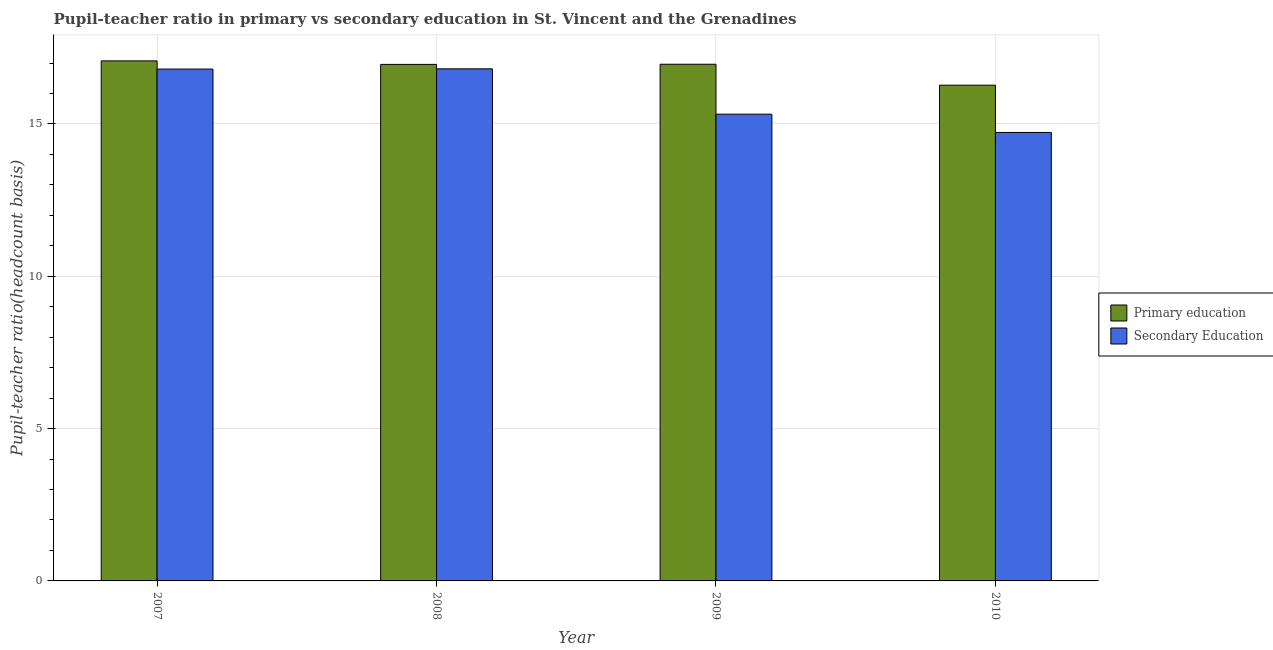How many groups of bars are there?
Offer a terse response. 4. Are the number of bars per tick equal to the number of legend labels?
Provide a succinct answer. Yes. Are the number of bars on each tick of the X-axis equal?
Your answer should be compact. Yes. How many bars are there on the 4th tick from the left?
Offer a terse response. 2. In how many cases, is the number of bars for a given year not equal to the number of legend labels?
Provide a succinct answer. 0. What is the pupil teacher ratio on secondary education in 2008?
Your answer should be very brief. 16.81. Across all years, what is the maximum pupil-teacher ratio in primary education?
Your response must be concise. 17.07. Across all years, what is the minimum pupil-teacher ratio in primary education?
Give a very brief answer. 16.27. In which year was the pupil-teacher ratio in primary education minimum?
Your answer should be very brief. 2010. What is the total pupil teacher ratio on secondary education in the graph?
Your response must be concise. 63.66. What is the difference between the pupil teacher ratio on secondary education in 2008 and that in 2010?
Keep it short and to the point. 2.09. What is the difference between the pupil teacher ratio on secondary education in 2008 and the pupil-teacher ratio in primary education in 2010?
Ensure brevity in your answer.  2.09. What is the average pupil teacher ratio on secondary education per year?
Your answer should be very brief. 15.91. In the year 2007, what is the difference between the pupil teacher ratio on secondary education and pupil-teacher ratio in primary education?
Make the answer very short. 0. In how many years, is the pupil teacher ratio on secondary education greater than 11?
Offer a very short reply. 4. What is the ratio of the pupil teacher ratio on secondary education in 2007 to that in 2008?
Your answer should be compact. 1. Is the pupil teacher ratio on secondary education in 2008 less than that in 2009?
Offer a very short reply. No. Is the difference between the pupil-teacher ratio in primary education in 2007 and 2009 greater than the difference between the pupil teacher ratio on secondary education in 2007 and 2009?
Offer a terse response. No. What is the difference between the highest and the second highest pupil teacher ratio on secondary education?
Provide a short and direct response. 0.01. What is the difference between the highest and the lowest pupil-teacher ratio in primary education?
Your answer should be very brief. 0.8. In how many years, is the pupil teacher ratio on secondary education greater than the average pupil teacher ratio on secondary education taken over all years?
Your answer should be very brief. 2. Is the sum of the pupil teacher ratio on secondary education in 2008 and 2009 greater than the maximum pupil-teacher ratio in primary education across all years?
Ensure brevity in your answer.  Yes. What does the 1st bar from the left in 2007 represents?
Ensure brevity in your answer.  Primary education. What does the 2nd bar from the right in 2010 represents?
Your answer should be very brief. Primary education. What is the difference between two consecutive major ticks on the Y-axis?
Your answer should be compact. 5. Are the values on the major ticks of Y-axis written in scientific E-notation?
Make the answer very short. No. Does the graph contain any zero values?
Keep it short and to the point. No. What is the title of the graph?
Your response must be concise. Pupil-teacher ratio in primary vs secondary education in St. Vincent and the Grenadines. What is the label or title of the Y-axis?
Ensure brevity in your answer.  Pupil-teacher ratio(headcount basis). What is the Pupil-teacher ratio(headcount basis) of Primary education in 2007?
Your answer should be compact. 17.07. What is the Pupil-teacher ratio(headcount basis) in Secondary Education in 2007?
Offer a terse response. 16.8. What is the Pupil-teacher ratio(headcount basis) in Primary education in 2008?
Offer a terse response. 16.96. What is the Pupil-teacher ratio(headcount basis) of Secondary Education in 2008?
Provide a succinct answer. 16.81. What is the Pupil-teacher ratio(headcount basis) in Primary education in 2009?
Provide a short and direct response. 16.96. What is the Pupil-teacher ratio(headcount basis) of Secondary Education in 2009?
Provide a succinct answer. 15.32. What is the Pupil-teacher ratio(headcount basis) in Primary education in 2010?
Keep it short and to the point. 16.27. What is the Pupil-teacher ratio(headcount basis) of Secondary Education in 2010?
Your answer should be very brief. 14.72. Across all years, what is the maximum Pupil-teacher ratio(headcount basis) in Primary education?
Make the answer very short. 17.07. Across all years, what is the maximum Pupil-teacher ratio(headcount basis) in Secondary Education?
Offer a very short reply. 16.81. Across all years, what is the minimum Pupil-teacher ratio(headcount basis) in Primary education?
Keep it short and to the point. 16.27. Across all years, what is the minimum Pupil-teacher ratio(headcount basis) of Secondary Education?
Your answer should be very brief. 14.72. What is the total Pupil-teacher ratio(headcount basis) of Primary education in the graph?
Keep it short and to the point. 67.26. What is the total Pupil-teacher ratio(headcount basis) in Secondary Education in the graph?
Your answer should be compact. 63.66. What is the difference between the Pupil-teacher ratio(headcount basis) in Primary education in 2007 and that in 2008?
Make the answer very short. 0.12. What is the difference between the Pupil-teacher ratio(headcount basis) in Secondary Education in 2007 and that in 2008?
Ensure brevity in your answer.  -0.01. What is the difference between the Pupil-teacher ratio(headcount basis) of Primary education in 2007 and that in 2009?
Your answer should be compact. 0.11. What is the difference between the Pupil-teacher ratio(headcount basis) in Secondary Education in 2007 and that in 2009?
Offer a very short reply. 1.48. What is the difference between the Pupil-teacher ratio(headcount basis) in Primary education in 2007 and that in 2010?
Give a very brief answer. 0.8. What is the difference between the Pupil-teacher ratio(headcount basis) of Secondary Education in 2007 and that in 2010?
Provide a short and direct response. 2.08. What is the difference between the Pupil-teacher ratio(headcount basis) in Primary education in 2008 and that in 2009?
Offer a terse response. -0.01. What is the difference between the Pupil-teacher ratio(headcount basis) of Secondary Education in 2008 and that in 2009?
Keep it short and to the point. 1.49. What is the difference between the Pupil-teacher ratio(headcount basis) in Primary education in 2008 and that in 2010?
Provide a succinct answer. 0.68. What is the difference between the Pupil-teacher ratio(headcount basis) of Secondary Education in 2008 and that in 2010?
Keep it short and to the point. 2.09. What is the difference between the Pupil-teacher ratio(headcount basis) in Primary education in 2009 and that in 2010?
Your answer should be compact. 0.69. What is the difference between the Pupil-teacher ratio(headcount basis) in Secondary Education in 2009 and that in 2010?
Your answer should be very brief. 0.6. What is the difference between the Pupil-teacher ratio(headcount basis) of Primary education in 2007 and the Pupil-teacher ratio(headcount basis) of Secondary Education in 2008?
Provide a succinct answer. 0.26. What is the difference between the Pupil-teacher ratio(headcount basis) in Primary education in 2007 and the Pupil-teacher ratio(headcount basis) in Secondary Education in 2009?
Your response must be concise. 1.75. What is the difference between the Pupil-teacher ratio(headcount basis) in Primary education in 2007 and the Pupil-teacher ratio(headcount basis) in Secondary Education in 2010?
Provide a succinct answer. 2.35. What is the difference between the Pupil-teacher ratio(headcount basis) in Primary education in 2008 and the Pupil-teacher ratio(headcount basis) in Secondary Education in 2009?
Offer a terse response. 1.63. What is the difference between the Pupil-teacher ratio(headcount basis) of Primary education in 2008 and the Pupil-teacher ratio(headcount basis) of Secondary Education in 2010?
Provide a short and direct response. 2.23. What is the difference between the Pupil-teacher ratio(headcount basis) in Primary education in 2009 and the Pupil-teacher ratio(headcount basis) in Secondary Education in 2010?
Ensure brevity in your answer.  2.24. What is the average Pupil-teacher ratio(headcount basis) of Primary education per year?
Provide a short and direct response. 16.82. What is the average Pupil-teacher ratio(headcount basis) in Secondary Education per year?
Offer a very short reply. 15.91. In the year 2007, what is the difference between the Pupil-teacher ratio(headcount basis) of Primary education and Pupil-teacher ratio(headcount basis) of Secondary Education?
Give a very brief answer. 0.27. In the year 2008, what is the difference between the Pupil-teacher ratio(headcount basis) of Primary education and Pupil-teacher ratio(headcount basis) of Secondary Education?
Provide a short and direct response. 0.15. In the year 2009, what is the difference between the Pupil-teacher ratio(headcount basis) of Primary education and Pupil-teacher ratio(headcount basis) of Secondary Education?
Your answer should be very brief. 1.64. In the year 2010, what is the difference between the Pupil-teacher ratio(headcount basis) of Primary education and Pupil-teacher ratio(headcount basis) of Secondary Education?
Provide a short and direct response. 1.55. What is the ratio of the Pupil-teacher ratio(headcount basis) in Primary education in 2007 to that in 2008?
Keep it short and to the point. 1.01. What is the ratio of the Pupil-teacher ratio(headcount basis) in Primary education in 2007 to that in 2009?
Keep it short and to the point. 1.01. What is the ratio of the Pupil-teacher ratio(headcount basis) of Secondary Education in 2007 to that in 2009?
Keep it short and to the point. 1.1. What is the ratio of the Pupil-teacher ratio(headcount basis) of Primary education in 2007 to that in 2010?
Provide a succinct answer. 1.05. What is the ratio of the Pupil-teacher ratio(headcount basis) of Secondary Education in 2007 to that in 2010?
Give a very brief answer. 1.14. What is the ratio of the Pupil-teacher ratio(headcount basis) of Secondary Education in 2008 to that in 2009?
Your response must be concise. 1.1. What is the ratio of the Pupil-teacher ratio(headcount basis) of Primary education in 2008 to that in 2010?
Your answer should be compact. 1.04. What is the ratio of the Pupil-teacher ratio(headcount basis) in Secondary Education in 2008 to that in 2010?
Provide a succinct answer. 1.14. What is the ratio of the Pupil-teacher ratio(headcount basis) in Primary education in 2009 to that in 2010?
Offer a terse response. 1.04. What is the ratio of the Pupil-teacher ratio(headcount basis) in Secondary Education in 2009 to that in 2010?
Give a very brief answer. 1.04. What is the difference between the highest and the second highest Pupil-teacher ratio(headcount basis) of Primary education?
Ensure brevity in your answer.  0.11. What is the difference between the highest and the second highest Pupil-teacher ratio(headcount basis) of Secondary Education?
Provide a short and direct response. 0.01. What is the difference between the highest and the lowest Pupil-teacher ratio(headcount basis) in Primary education?
Ensure brevity in your answer.  0.8. What is the difference between the highest and the lowest Pupil-teacher ratio(headcount basis) in Secondary Education?
Offer a very short reply. 2.09. 